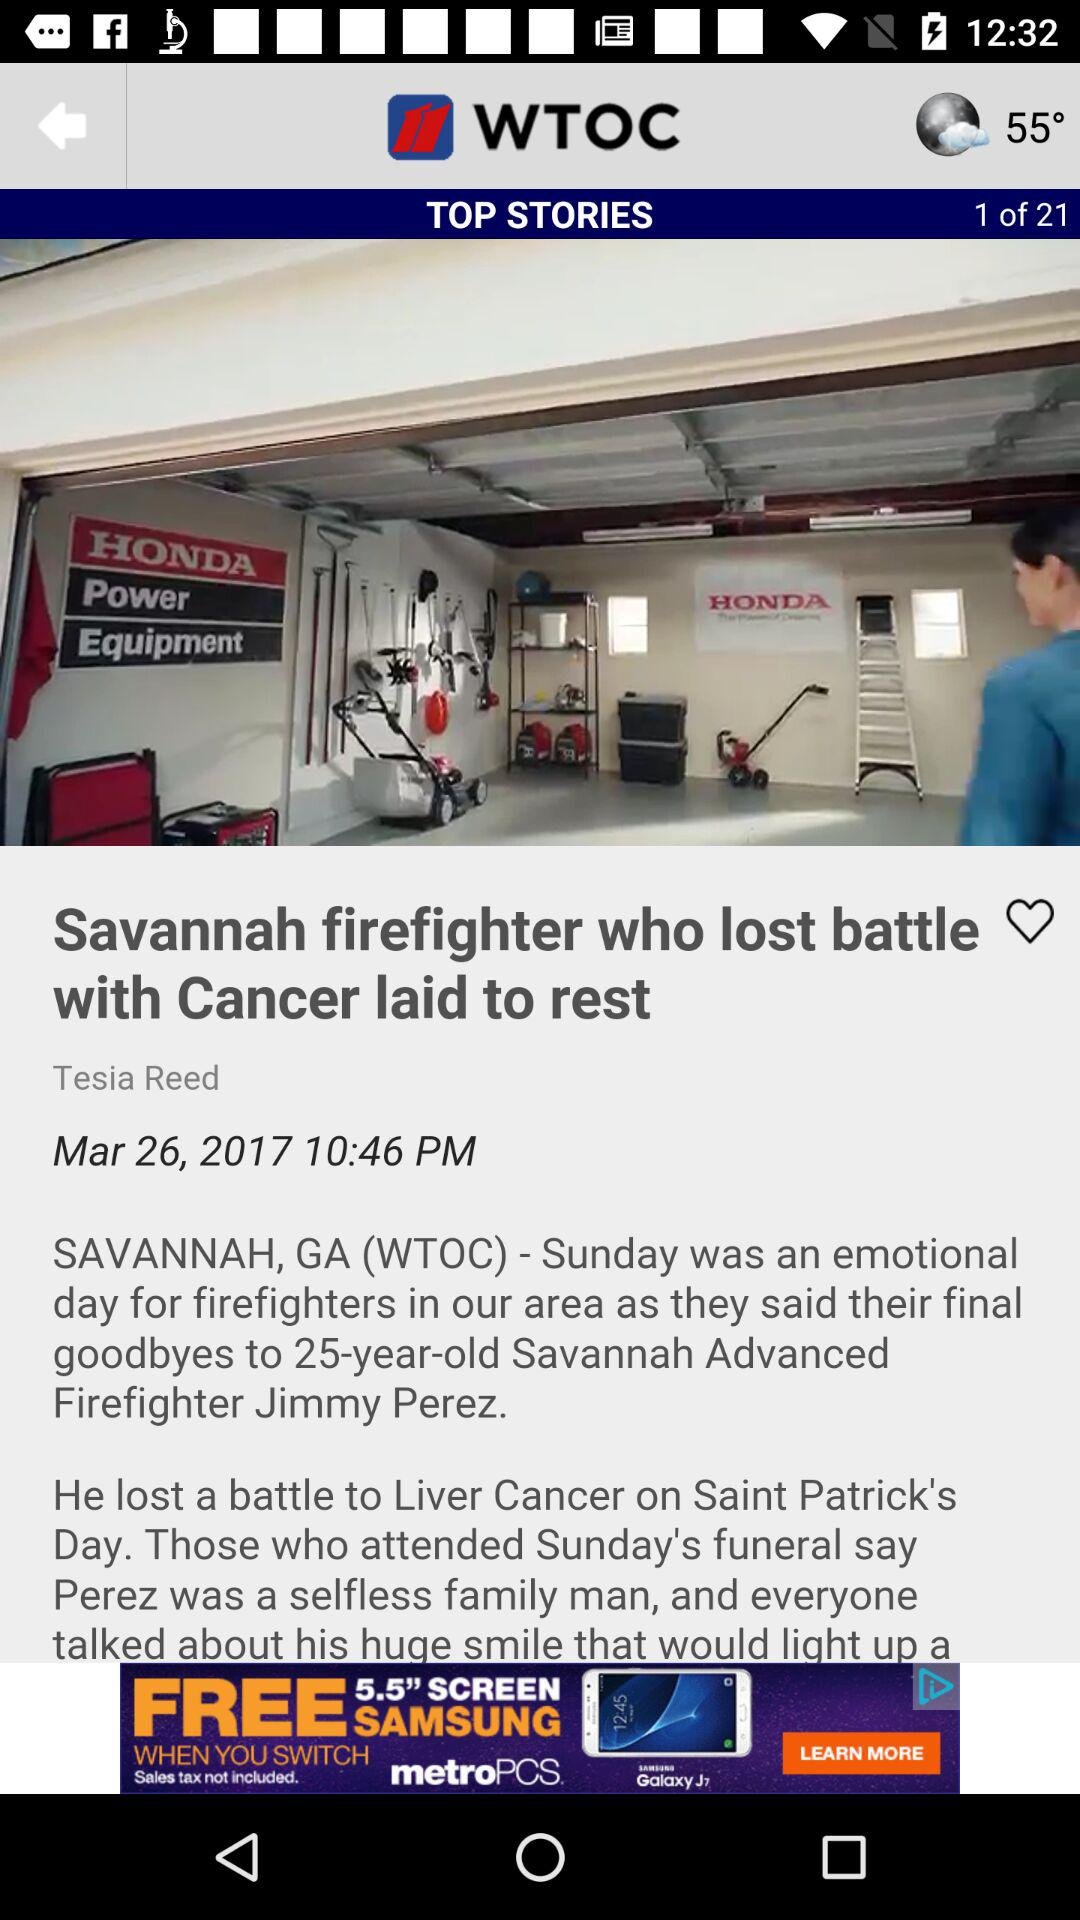What is the publication date of the article? The publication date of the article is March 26, 2017. 